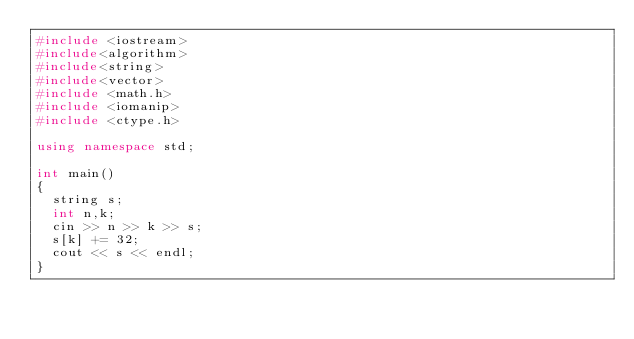Convert code to text. <code><loc_0><loc_0><loc_500><loc_500><_C++_>#include <iostream>
#include<algorithm>
#include<string>
#include<vector>
#include <math.h>
#include <iomanip>
#include <ctype.h>

using namespace std;

int main()
{
	string s;
	int n,k;
	cin >> n >> k >> s;
	s[k] += 32;
	cout << s << endl;
}</code> 